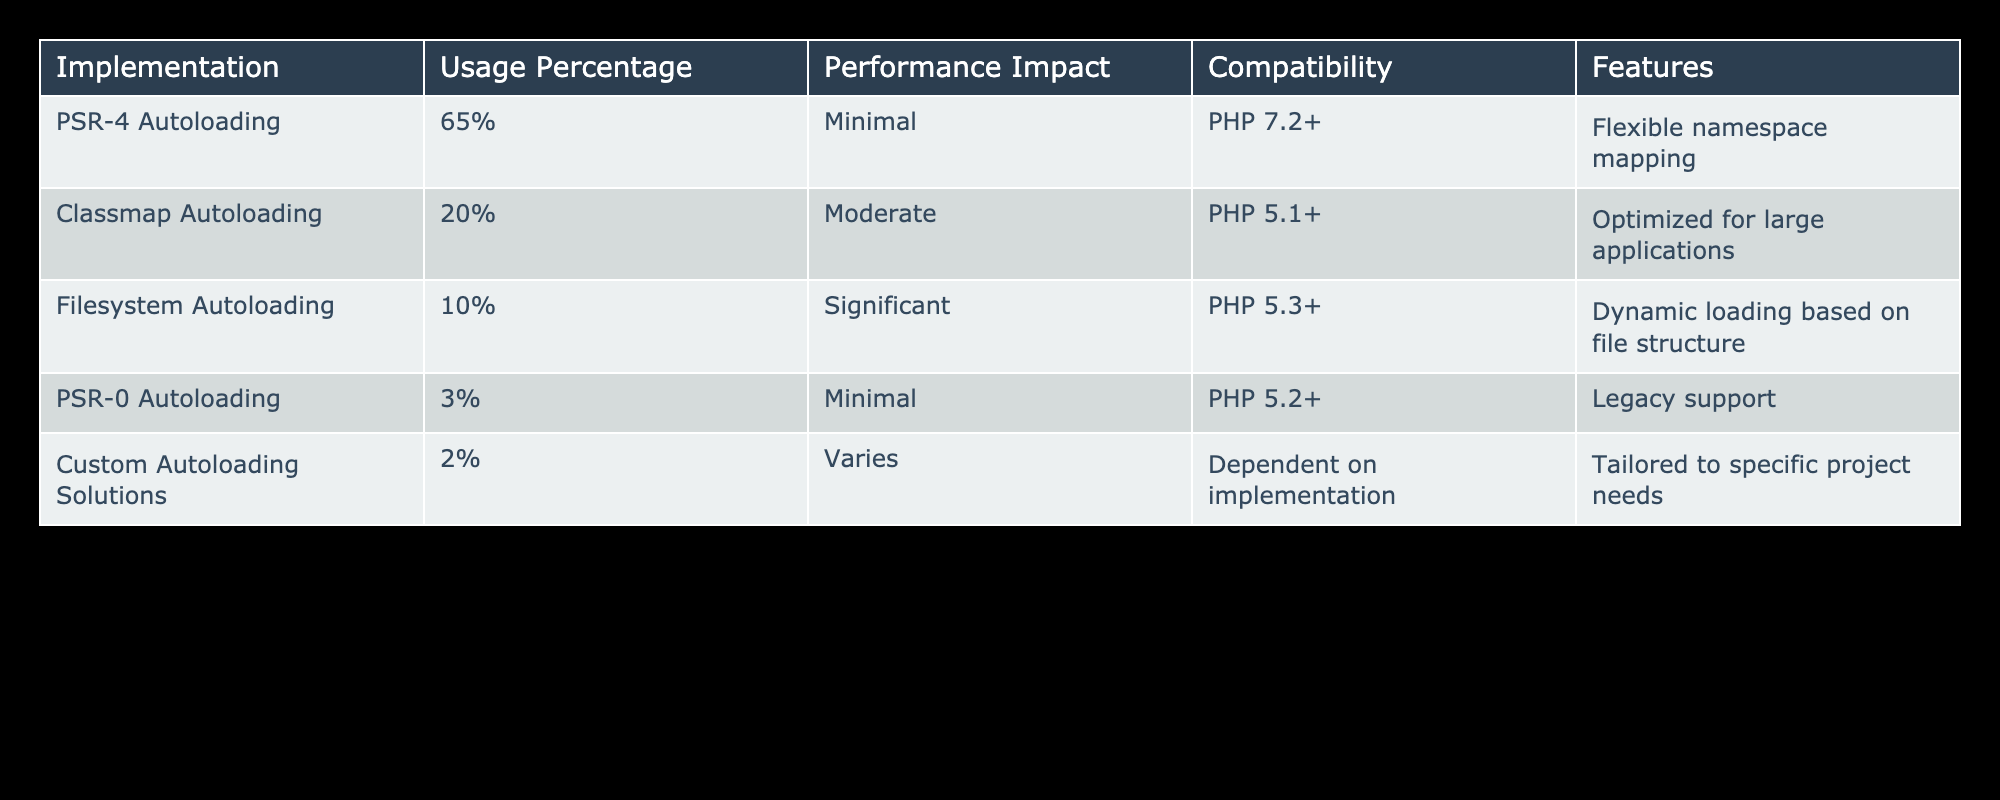What is the usage percentage of PSR-4 Autoloading? The table shows that the usage percentage of PSR-4 Autoloading is 65%.
Answer: 65% How many autoloading implementations have a minimal performance impact? According to the table, there are two implementations (PSR-4 Autoloading and PSR-0 Autoloading) that have a minimal performance impact.
Answer: 2 What is the total percentage of usage for Classmap and Filesystem Autoloading? By adding the usage percentages of Classmap (20%) and Filesystem (10%), the total is 20% + 10% = 30%.
Answer: 30% Is it true that Custom Autoloading Solutions have a compatibility with PHP 8.x? The table states that Custom Autoloading Solutions are dependent on implementation, but since they are tailored to specific project needs, which likely includes PHP 8.x, we can conclude it is true.
Answer: Yes Which autoloading method has the highest compatibility version requirement? By reviewing the table, Classmap Autoloading requires PHP 5.1+, which is the highest among the listed compatibility versions.
Answer: PHP 5.1+ What is the median performance impact of the autoloading implementations listed? The performance impacts are Minimal, Moderate, Significant, and Varies. When represented numerically (Minimal=1, Moderate=2, Significant=3, Varies=4), the median performance impact (the average of the two middle values when sorted) is Moderate, as they can be ranked as Minimal, Minimal, Moderate, Significant, Varies.
Answer: Moderate How many autoloading implementations are compatible with PHP 5.3 or lower? The table lists Filesystem Autoloading with a requirement of PHP 5.3+, as well as PSR-0 Autoloading at PHP 5.2+ and Custom Autoloading Solutions with dependent implementation, totaling three implementations that meet or have lower compatibility.
Answer: 3 What is the feature of Classmap Autoloading? According to the table, Classmap Autoloading is optimized for large applications.
Answer: Optimized for large applications Which autoloading method has the lowest usage percentage and what is it? Referring to the table, Custom Autoloading Solutions have the lowest usage percentage at 2%.
Answer: 2% 